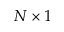<formula> <loc_0><loc_0><loc_500><loc_500>N \times 1</formula> 